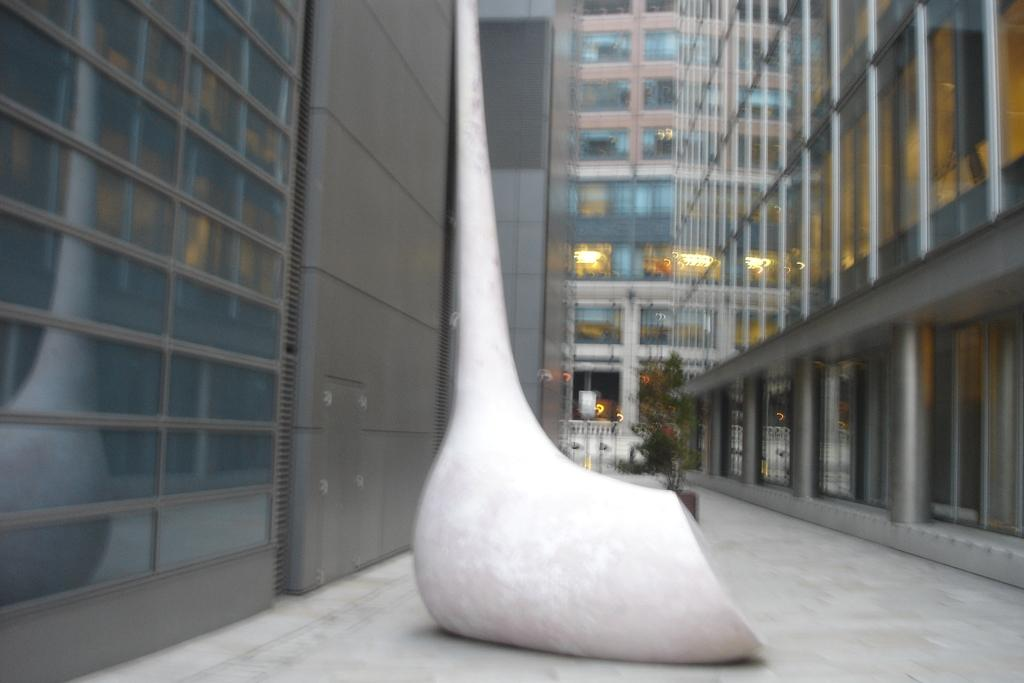What is the main subject of the image? There is a white object in the image. How would you describe the appearance of the background in the image? The background of the image is blurry. What type of structures can be seen in the background of the image? There are buildings visible in the background of the image. What type of vegetation is present in the background of the image? There is a plant in the background of the image. Can you describe the arch that the sail is jumping over in the image? There is no arch, sail, or jumping activity present in the image. 